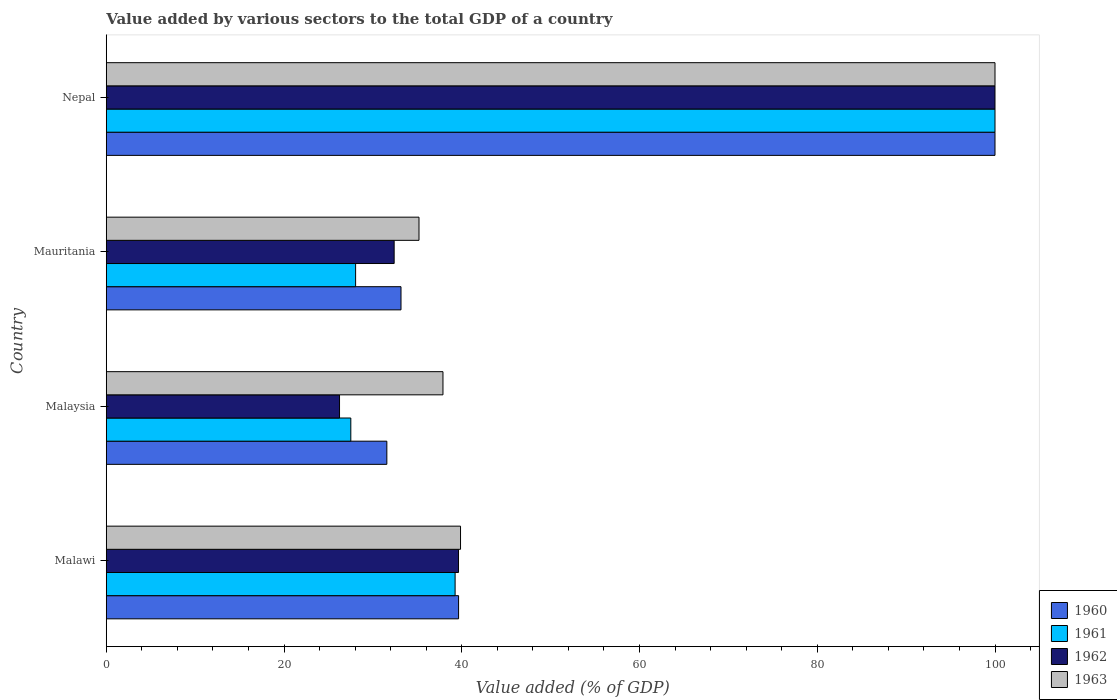How many different coloured bars are there?
Offer a terse response. 4. How many bars are there on the 4th tick from the bottom?
Offer a very short reply. 4. What is the label of the 4th group of bars from the top?
Ensure brevity in your answer.  Malawi. Across all countries, what is the minimum value added by various sectors to the total GDP in 1960?
Your answer should be compact. 31.57. In which country was the value added by various sectors to the total GDP in 1961 maximum?
Your answer should be very brief. Nepal. In which country was the value added by various sectors to the total GDP in 1963 minimum?
Make the answer very short. Mauritania. What is the total value added by various sectors to the total GDP in 1961 in the graph?
Offer a very short reply. 194.83. What is the difference between the value added by various sectors to the total GDP in 1960 in Malawi and that in Mauritania?
Offer a terse response. 6.48. What is the difference between the value added by various sectors to the total GDP in 1962 in Mauritania and the value added by various sectors to the total GDP in 1960 in Malawi?
Give a very brief answer. -7.25. What is the average value added by various sectors to the total GDP in 1962 per country?
Keep it short and to the point. 49.57. What is the difference between the value added by various sectors to the total GDP in 1960 and value added by various sectors to the total GDP in 1961 in Nepal?
Ensure brevity in your answer.  0. In how many countries, is the value added by various sectors to the total GDP in 1960 greater than 48 %?
Provide a succinct answer. 1. What is the ratio of the value added by various sectors to the total GDP in 1960 in Malawi to that in Nepal?
Provide a short and direct response. 0.4. Is the difference between the value added by various sectors to the total GDP in 1960 in Mauritania and Nepal greater than the difference between the value added by various sectors to the total GDP in 1961 in Mauritania and Nepal?
Offer a very short reply. Yes. What is the difference between the highest and the second highest value added by various sectors to the total GDP in 1960?
Your answer should be compact. 60.36. What is the difference between the highest and the lowest value added by various sectors to the total GDP in 1963?
Your answer should be compact. 64.81. Is the sum of the value added by various sectors to the total GDP in 1961 in Malaysia and Nepal greater than the maximum value added by various sectors to the total GDP in 1960 across all countries?
Provide a short and direct response. Yes. What is the difference between two consecutive major ticks on the X-axis?
Offer a very short reply. 20. Does the graph contain any zero values?
Offer a terse response. No. Does the graph contain grids?
Your response must be concise. No. Where does the legend appear in the graph?
Offer a very short reply. Bottom right. How many legend labels are there?
Offer a very short reply. 4. How are the legend labels stacked?
Provide a short and direct response. Vertical. What is the title of the graph?
Provide a short and direct response. Value added by various sectors to the total GDP of a country. What is the label or title of the X-axis?
Your response must be concise. Value added (% of GDP). What is the label or title of the Y-axis?
Provide a succinct answer. Country. What is the Value added (% of GDP) in 1960 in Malawi?
Offer a terse response. 39.64. What is the Value added (% of GDP) in 1961 in Malawi?
Provide a short and direct response. 39.25. What is the Value added (% of GDP) in 1962 in Malawi?
Your response must be concise. 39.64. What is the Value added (% of GDP) in 1963 in Malawi?
Make the answer very short. 39.86. What is the Value added (% of GDP) of 1960 in Malaysia?
Ensure brevity in your answer.  31.57. What is the Value added (% of GDP) in 1961 in Malaysia?
Offer a terse response. 27.52. What is the Value added (% of GDP) in 1962 in Malaysia?
Provide a succinct answer. 26.25. What is the Value added (% of GDP) of 1963 in Malaysia?
Make the answer very short. 37.89. What is the Value added (% of GDP) in 1960 in Mauritania?
Your response must be concise. 33.17. What is the Value added (% of GDP) of 1961 in Mauritania?
Your answer should be very brief. 28.06. What is the Value added (% of GDP) of 1962 in Mauritania?
Make the answer very short. 32.4. What is the Value added (% of GDP) of 1963 in Mauritania?
Your response must be concise. 35.19. What is the Value added (% of GDP) of 1960 in Nepal?
Give a very brief answer. 100. What is the Value added (% of GDP) in 1961 in Nepal?
Provide a succinct answer. 100. What is the Value added (% of GDP) in 1962 in Nepal?
Your response must be concise. 100. Across all countries, what is the maximum Value added (% of GDP) of 1961?
Offer a terse response. 100. Across all countries, what is the minimum Value added (% of GDP) in 1960?
Keep it short and to the point. 31.57. Across all countries, what is the minimum Value added (% of GDP) in 1961?
Your answer should be very brief. 27.52. Across all countries, what is the minimum Value added (% of GDP) in 1962?
Ensure brevity in your answer.  26.25. Across all countries, what is the minimum Value added (% of GDP) of 1963?
Keep it short and to the point. 35.19. What is the total Value added (% of GDP) in 1960 in the graph?
Provide a short and direct response. 204.38. What is the total Value added (% of GDP) of 1961 in the graph?
Provide a succinct answer. 194.83. What is the total Value added (% of GDP) of 1962 in the graph?
Provide a short and direct response. 198.28. What is the total Value added (% of GDP) of 1963 in the graph?
Make the answer very short. 212.94. What is the difference between the Value added (% of GDP) of 1960 in Malawi and that in Malaysia?
Offer a terse response. 8.07. What is the difference between the Value added (% of GDP) of 1961 in Malawi and that in Malaysia?
Your response must be concise. 11.73. What is the difference between the Value added (% of GDP) of 1962 in Malawi and that in Malaysia?
Give a very brief answer. 13.39. What is the difference between the Value added (% of GDP) of 1963 in Malawi and that in Malaysia?
Your answer should be very brief. 1.98. What is the difference between the Value added (% of GDP) in 1960 in Malawi and that in Mauritania?
Your answer should be compact. 6.48. What is the difference between the Value added (% of GDP) of 1961 in Malawi and that in Mauritania?
Provide a short and direct response. 11.2. What is the difference between the Value added (% of GDP) of 1962 in Malawi and that in Mauritania?
Offer a terse response. 7.24. What is the difference between the Value added (% of GDP) in 1963 in Malawi and that in Mauritania?
Offer a terse response. 4.67. What is the difference between the Value added (% of GDP) in 1960 in Malawi and that in Nepal?
Your answer should be very brief. -60.36. What is the difference between the Value added (% of GDP) in 1961 in Malawi and that in Nepal?
Provide a succinct answer. -60.75. What is the difference between the Value added (% of GDP) of 1962 in Malawi and that in Nepal?
Your response must be concise. -60.36. What is the difference between the Value added (% of GDP) of 1963 in Malawi and that in Nepal?
Your answer should be compact. -60.14. What is the difference between the Value added (% of GDP) of 1960 in Malaysia and that in Mauritania?
Keep it short and to the point. -1.59. What is the difference between the Value added (% of GDP) in 1961 in Malaysia and that in Mauritania?
Offer a terse response. -0.54. What is the difference between the Value added (% of GDP) in 1962 in Malaysia and that in Mauritania?
Ensure brevity in your answer.  -6.15. What is the difference between the Value added (% of GDP) of 1963 in Malaysia and that in Mauritania?
Your response must be concise. 2.7. What is the difference between the Value added (% of GDP) of 1960 in Malaysia and that in Nepal?
Offer a terse response. -68.43. What is the difference between the Value added (% of GDP) of 1961 in Malaysia and that in Nepal?
Give a very brief answer. -72.48. What is the difference between the Value added (% of GDP) of 1962 in Malaysia and that in Nepal?
Keep it short and to the point. -73.75. What is the difference between the Value added (% of GDP) in 1963 in Malaysia and that in Nepal?
Offer a terse response. -62.11. What is the difference between the Value added (% of GDP) in 1960 in Mauritania and that in Nepal?
Your answer should be very brief. -66.83. What is the difference between the Value added (% of GDP) of 1961 in Mauritania and that in Nepal?
Your answer should be compact. -71.94. What is the difference between the Value added (% of GDP) of 1962 in Mauritania and that in Nepal?
Give a very brief answer. -67.6. What is the difference between the Value added (% of GDP) of 1963 in Mauritania and that in Nepal?
Offer a very short reply. -64.81. What is the difference between the Value added (% of GDP) in 1960 in Malawi and the Value added (% of GDP) in 1961 in Malaysia?
Give a very brief answer. 12.13. What is the difference between the Value added (% of GDP) in 1960 in Malawi and the Value added (% of GDP) in 1962 in Malaysia?
Make the answer very short. 13.39. What is the difference between the Value added (% of GDP) of 1960 in Malawi and the Value added (% of GDP) of 1963 in Malaysia?
Give a very brief answer. 1.76. What is the difference between the Value added (% of GDP) in 1961 in Malawi and the Value added (% of GDP) in 1962 in Malaysia?
Offer a very short reply. 13. What is the difference between the Value added (% of GDP) in 1961 in Malawi and the Value added (% of GDP) in 1963 in Malaysia?
Your answer should be compact. 1.37. What is the difference between the Value added (% of GDP) of 1962 in Malawi and the Value added (% of GDP) of 1963 in Malaysia?
Provide a succinct answer. 1.75. What is the difference between the Value added (% of GDP) of 1960 in Malawi and the Value added (% of GDP) of 1961 in Mauritania?
Your answer should be compact. 11.59. What is the difference between the Value added (% of GDP) in 1960 in Malawi and the Value added (% of GDP) in 1962 in Mauritania?
Provide a succinct answer. 7.25. What is the difference between the Value added (% of GDP) in 1960 in Malawi and the Value added (% of GDP) in 1963 in Mauritania?
Your answer should be compact. 4.45. What is the difference between the Value added (% of GDP) of 1961 in Malawi and the Value added (% of GDP) of 1962 in Mauritania?
Your answer should be compact. 6.86. What is the difference between the Value added (% of GDP) in 1961 in Malawi and the Value added (% of GDP) in 1963 in Mauritania?
Give a very brief answer. 4.06. What is the difference between the Value added (% of GDP) of 1962 in Malawi and the Value added (% of GDP) of 1963 in Mauritania?
Ensure brevity in your answer.  4.45. What is the difference between the Value added (% of GDP) of 1960 in Malawi and the Value added (% of GDP) of 1961 in Nepal?
Offer a terse response. -60.36. What is the difference between the Value added (% of GDP) in 1960 in Malawi and the Value added (% of GDP) in 1962 in Nepal?
Offer a very short reply. -60.36. What is the difference between the Value added (% of GDP) of 1960 in Malawi and the Value added (% of GDP) of 1963 in Nepal?
Ensure brevity in your answer.  -60.36. What is the difference between the Value added (% of GDP) in 1961 in Malawi and the Value added (% of GDP) in 1962 in Nepal?
Your answer should be compact. -60.75. What is the difference between the Value added (% of GDP) in 1961 in Malawi and the Value added (% of GDP) in 1963 in Nepal?
Make the answer very short. -60.75. What is the difference between the Value added (% of GDP) of 1962 in Malawi and the Value added (% of GDP) of 1963 in Nepal?
Keep it short and to the point. -60.36. What is the difference between the Value added (% of GDP) of 1960 in Malaysia and the Value added (% of GDP) of 1961 in Mauritania?
Your response must be concise. 3.51. What is the difference between the Value added (% of GDP) in 1960 in Malaysia and the Value added (% of GDP) in 1962 in Mauritania?
Offer a terse response. -0.82. What is the difference between the Value added (% of GDP) of 1960 in Malaysia and the Value added (% of GDP) of 1963 in Mauritania?
Your answer should be compact. -3.62. What is the difference between the Value added (% of GDP) in 1961 in Malaysia and the Value added (% of GDP) in 1962 in Mauritania?
Offer a very short reply. -4.88. What is the difference between the Value added (% of GDP) in 1961 in Malaysia and the Value added (% of GDP) in 1963 in Mauritania?
Provide a short and direct response. -7.67. What is the difference between the Value added (% of GDP) of 1962 in Malaysia and the Value added (% of GDP) of 1963 in Mauritania?
Offer a terse response. -8.94. What is the difference between the Value added (% of GDP) of 1960 in Malaysia and the Value added (% of GDP) of 1961 in Nepal?
Your answer should be compact. -68.43. What is the difference between the Value added (% of GDP) in 1960 in Malaysia and the Value added (% of GDP) in 1962 in Nepal?
Your answer should be compact. -68.43. What is the difference between the Value added (% of GDP) in 1960 in Malaysia and the Value added (% of GDP) in 1963 in Nepal?
Your answer should be very brief. -68.43. What is the difference between the Value added (% of GDP) of 1961 in Malaysia and the Value added (% of GDP) of 1962 in Nepal?
Provide a short and direct response. -72.48. What is the difference between the Value added (% of GDP) of 1961 in Malaysia and the Value added (% of GDP) of 1963 in Nepal?
Keep it short and to the point. -72.48. What is the difference between the Value added (% of GDP) of 1962 in Malaysia and the Value added (% of GDP) of 1963 in Nepal?
Ensure brevity in your answer.  -73.75. What is the difference between the Value added (% of GDP) in 1960 in Mauritania and the Value added (% of GDP) in 1961 in Nepal?
Your response must be concise. -66.83. What is the difference between the Value added (% of GDP) of 1960 in Mauritania and the Value added (% of GDP) of 1962 in Nepal?
Ensure brevity in your answer.  -66.83. What is the difference between the Value added (% of GDP) in 1960 in Mauritania and the Value added (% of GDP) in 1963 in Nepal?
Provide a succinct answer. -66.83. What is the difference between the Value added (% of GDP) of 1961 in Mauritania and the Value added (% of GDP) of 1962 in Nepal?
Give a very brief answer. -71.94. What is the difference between the Value added (% of GDP) in 1961 in Mauritania and the Value added (% of GDP) in 1963 in Nepal?
Your response must be concise. -71.94. What is the difference between the Value added (% of GDP) of 1962 in Mauritania and the Value added (% of GDP) of 1963 in Nepal?
Your response must be concise. -67.6. What is the average Value added (% of GDP) of 1960 per country?
Your answer should be compact. 51.1. What is the average Value added (% of GDP) in 1961 per country?
Ensure brevity in your answer.  48.71. What is the average Value added (% of GDP) in 1962 per country?
Offer a very short reply. 49.57. What is the average Value added (% of GDP) of 1963 per country?
Offer a terse response. 53.24. What is the difference between the Value added (% of GDP) in 1960 and Value added (% of GDP) in 1961 in Malawi?
Make the answer very short. 0.39. What is the difference between the Value added (% of GDP) in 1960 and Value added (% of GDP) in 1962 in Malawi?
Keep it short and to the point. 0.01. What is the difference between the Value added (% of GDP) in 1960 and Value added (% of GDP) in 1963 in Malawi?
Make the answer very short. -0.22. What is the difference between the Value added (% of GDP) in 1961 and Value added (% of GDP) in 1962 in Malawi?
Make the answer very short. -0.38. What is the difference between the Value added (% of GDP) of 1961 and Value added (% of GDP) of 1963 in Malawi?
Provide a succinct answer. -0.61. What is the difference between the Value added (% of GDP) of 1962 and Value added (% of GDP) of 1963 in Malawi?
Ensure brevity in your answer.  -0.23. What is the difference between the Value added (% of GDP) of 1960 and Value added (% of GDP) of 1961 in Malaysia?
Provide a succinct answer. 4.05. What is the difference between the Value added (% of GDP) in 1960 and Value added (% of GDP) in 1962 in Malaysia?
Your response must be concise. 5.32. What is the difference between the Value added (% of GDP) in 1960 and Value added (% of GDP) in 1963 in Malaysia?
Your response must be concise. -6.31. What is the difference between the Value added (% of GDP) in 1961 and Value added (% of GDP) in 1962 in Malaysia?
Make the answer very short. 1.27. What is the difference between the Value added (% of GDP) in 1961 and Value added (% of GDP) in 1963 in Malaysia?
Make the answer very short. -10.37. What is the difference between the Value added (% of GDP) in 1962 and Value added (% of GDP) in 1963 in Malaysia?
Ensure brevity in your answer.  -11.64. What is the difference between the Value added (% of GDP) in 1960 and Value added (% of GDP) in 1961 in Mauritania?
Give a very brief answer. 5.11. What is the difference between the Value added (% of GDP) of 1960 and Value added (% of GDP) of 1962 in Mauritania?
Ensure brevity in your answer.  0.77. What is the difference between the Value added (% of GDP) in 1960 and Value added (% of GDP) in 1963 in Mauritania?
Ensure brevity in your answer.  -2.02. What is the difference between the Value added (% of GDP) of 1961 and Value added (% of GDP) of 1962 in Mauritania?
Provide a short and direct response. -4.34. What is the difference between the Value added (% of GDP) of 1961 and Value added (% of GDP) of 1963 in Mauritania?
Your answer should be compact. -7.13. What is the difference between the Value added (% of GDP) of 1962 and Value added (% of GDP) of 1963 in Mauritania?
Your answer should be very brief. -2.79. What is the difference between the Value added (% of GDP) in 1960 and Value added (% of GDP) in 1961 in Nepal?
Your response must be concise. 0. What is the difference between the Value added (% of GDP) of 1960 and Value added (% of GDP) of 1963 in Nepal?
Keep it short and to the point. 0. What is the difference between the Value added (% of GDP) of 1961 and Value added (% of GDP) of 1962 in Nepal?
Your response must be concise. 0. What is the difference between the Value added (% of GDP) of 1961 and Value added (% of GDP) of 1963 in Nepal?
Your answer should be very brief. 0. What is the difference between the Value added (% of GDP) of 1962 and Value added (% of GDP) of 1963 in Nepal?
Keep it short and to the point. 0. What is the ratio of the Value added (% of GDP) of 1960 in Malawi to that in Malaysia?
Give a very brief answer. 1.26. What is the ratio of the Value added (% of GDP) in 1961 in Malawi to that in Malaysia?
Your response must be concise. 1.43. What is the ratio of the Value added (% of GDP) of 1962 in Malawi to that in Malaysia?
Your response must be concise. 1.51. What is the ratio of the Value added (% of GDP) of 1963 in Malawi to that in Malaysia?
Offer a terse response. 1.05. What is the ratio of the Value added (% of GDP) in 1960 in Malawi to that in Mauritania?
Give a very brief answer. 1.2. What is the ratio of the Value added (% of GDP) of 1961 in Malawi to that in Mauritania?
Offer a very short reply. 1.4. What is the ratio of the Value added (% of GDP) of 1962 in Malawi to that in Mauritania?
Offer a very short reply. 1.22. What is the ratio of the Value added (% of GDP) of 1963 in Malawi to that in Mauritania?
Offer a very short reply. 1.13. What is the ratio of the Value added (% of GDP) in 1960 in Malawi to that in Nepal?
Ensure brevity in your answer.  0.4. What is the ratio of the Value added (% of GDP) of 1961 in Malawi to that in Nepal?
Make the answer very short. 0.39. What is the ratio of the Value added (% of GDP) in 1962 in Malawi to that in Nepal?
Make the answer very short. 0.4. What is the ratio of the Value added (% of GDP) in 1963 in Malawi to that in Nepal?
Make the answer very short. 0.4. What is the ratio of the Value added (% of GDP) of 1961 in Malaysia to that in Mauritania?
Give a very brief answer. 0.98. What is the ratio of the Value added (% of GDP) in 1962 in Malaysia to that in Mauritania?
Offer a terse response. 0.81. What is the ratio of the Value added (% of GDP) in 1963 in Malaysia to that in Mauritania?
Give a very brief answer. 1.08. What is the ratio of the Value added (% of GDP) in 1960 in Malaysia to that in Nepal?
Offer a very short reply. 0.32. What is the ratio of the Value added (% of GDP) of 1961 in Malaysia to that in Nepal?
Provide a succinct answer. 0.28. What is the ratio of the Value added (% of GDP) in 1962 in Malaysia to that in Nepal?
Your answer should be compact. 0.26. What is the ratio of the Value added (% of GDP) of 1963 in Malaysia to that in Nepal?
Make the answer very short. 0.38. What is the ratio of the Value added (% of GDP) of 1960 in Mauritania to that in Nepal?
Your answer should be compact. 0.33. What is the ratio of the Value added (% of GDP) of 1961 in Mauritania to that in Nepal?
Provide a succinct answer. 0.28. What is the ratio of the Value added (% of GDP) of 1962 in Mauritania to that in Nepal?
Give a very brief answer. 0.32. What is the ratio of the Value added (% of GDP) in 1963 in Mauritania to that in Nepal?
Offer a terse response. 0.35. What is the difference between the highest and the second highest Value added (% of GDP) of 1960?
Keep it short and to the point. 60.36. What is the difference between the highest and the second highest Value added (% of GDP) in 1961?
Provide a succinct answer. 60.75. What is the difference between the highest and the second highest Value added (% of GDP) in 1962?
Make the answer very short. 60.36. What is the difference between the highest and the second highest Value added (% of GDP) of 1963?
Make the answer very short. 60.14. What is the difference between the highest and the lowest Value added (% of GDP) of 1960?
Keep it short and to the point. 68.43. What is the difference between the highest and the lowest Value added (% of GDP) of 1961?
Offer a very short reply. 72.48. What is the difference between the highest and the lowest Value added (% of GDP) of 1962?
Your answer should be very brief. 73.75. What is the difference between the highest and the lowest Value added (% of GDP) of 1963?
Offer a very short reply. 64.81. 